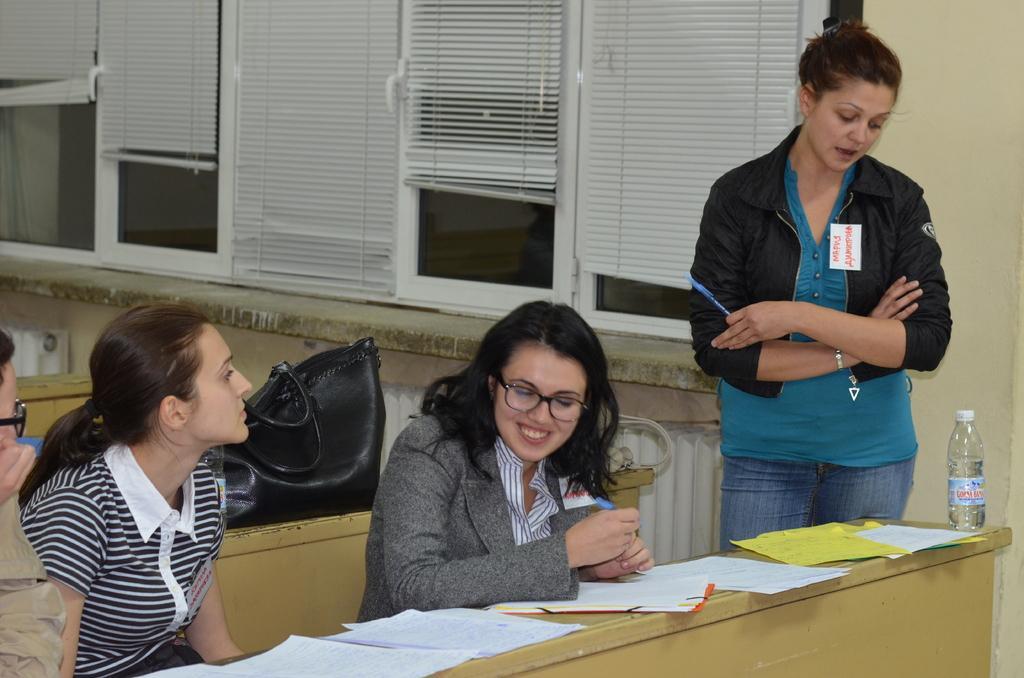In one or two sentences, can you explain what this image depicts? This picture describe about classroom. In front we ca see a girl sitting on the wooden bench and smiling. On the bench we can see many paper sand water bottle. Beside we can see a girl wearing black color jacket, standing and looking in the papers. Behind we can see glass window with white blinds on it. 